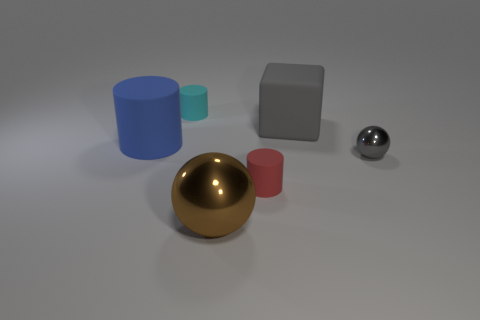Do the cylinder in front of the gray ball and the small metallic thing have the same size?
Provide a short and direct response. Yes. What number of things are red things or large brown spheres?
Ensure brevity in your answer.  2. The large object that is the same color as the small metal object is what shape?
Offer a terse response. Cube. There is a object that is both to the left of the small red rubber cylinder and in front of the gray metal ball; how big is it?
Provide a succinct answer. Large. How many blue rubber cylinders are there?
Your answer should be very brief. 1. What number of cylinders are either yellow rubber objects or large blue rubber objects?
Make the answer very short. 1. There is a gray thing in front of the big matte object that is left of the big ball; what number of tiny gray metal objects are in front of it?
Provide a short and direct response. 0. What is the color of the matte object that is the same size as the red matte cylinder?
Ensure brevity in your answer.  Cyan. What number of other objects are there of the same color as the large shiny thing?
Your answer should be compact. 0. Is the number of small gray spheres in front of the big cube greater than the number of tiny brown matte cylinders?
Ensure brevity in your answer.  Yes. 